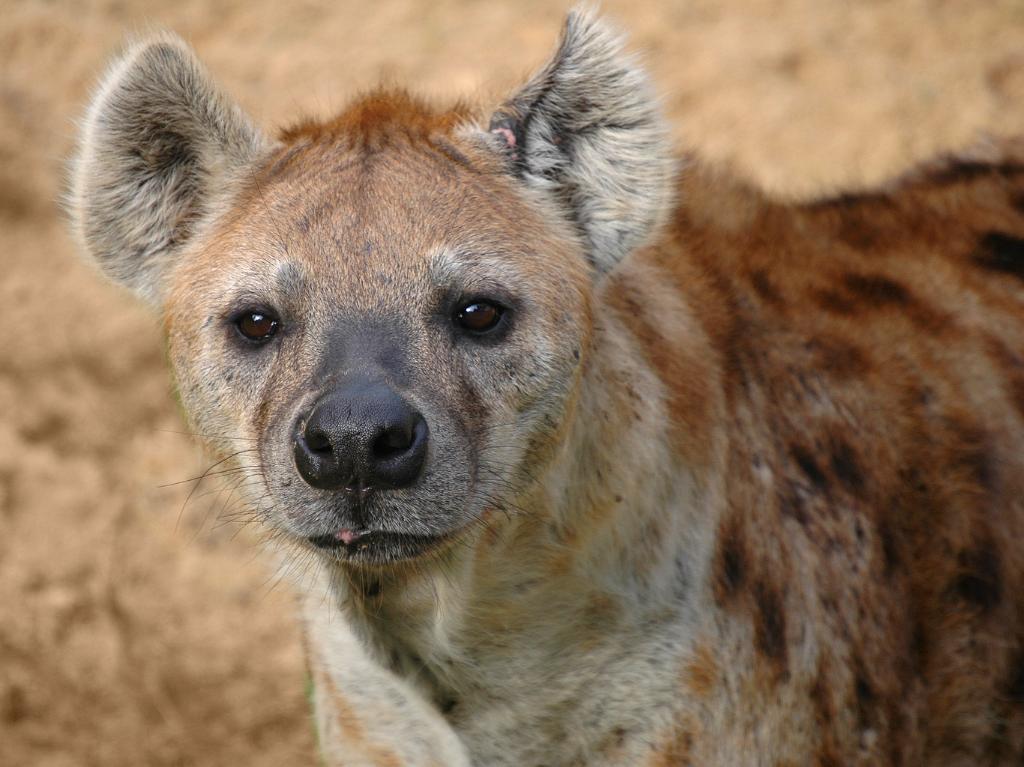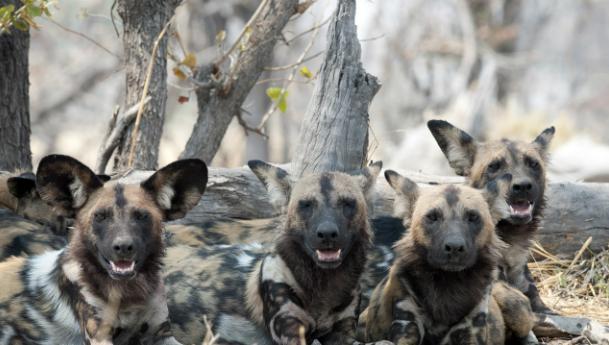The first image is the image on the left, the second image is the image on the right. For the images displayed, is the sentence "There is a single hyena in the image on the left." factually correct? Answer yes or no. Yes. The first image is the image on the left, the second image is the image on the right. Evaluate the accuracy of this statement regarding the images: "The lefthand image contains a single hyena, and the right image contains at least four hyena.". Is it true? Answer yes or no. Yes. 